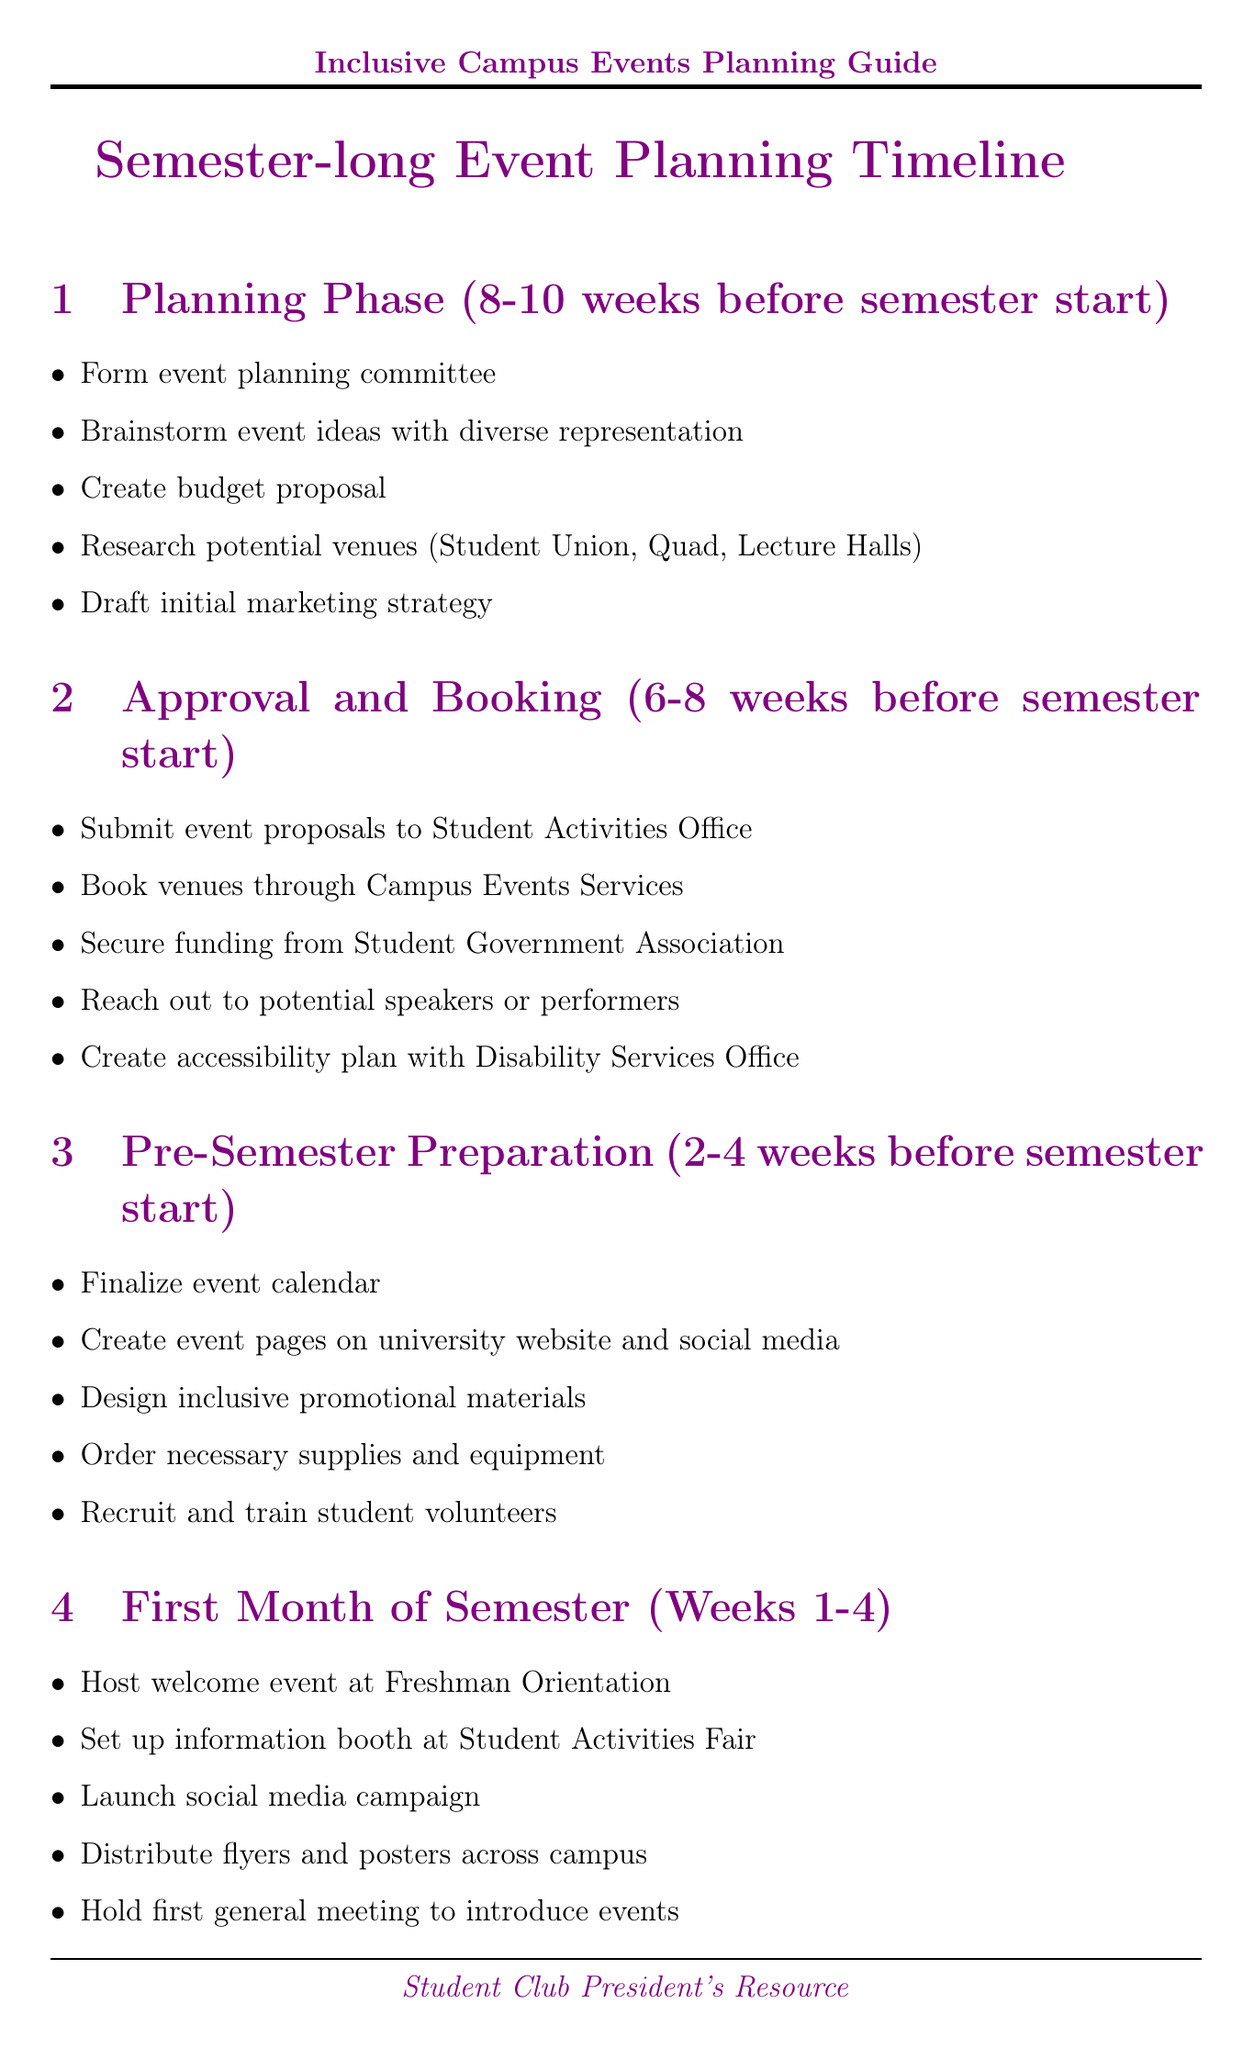what is the timeline for the Planning Phase? The timeline for the Planning Phase is specified as "8-10 weeks before semester start".
Answer: 8-10 weeks before semester start who is the Campus Events Coordinator? The document lists Michael Lee as the Campus Events Coordinator.
Answer: Michael Lee when is the Room Reservation Deadline? The Room Reservation Deadline is detailed as "4 weeks before semester start".
Answer: 4 weeks before semester start what task involves diverse representation? The task that involves diverse representation is "Brainstorm event ideas with diverse representation".
Answer: Brainstorm event ideas with diverse representation what should be created with the Disability Services Office? The document specifies that an "accessibility plan" should be created with the Disability Services Office.
Answer: accessibility plan how many tasks are listed for the End-of-Semester Wrap-up? The End-of-Semester Wrap-up section includes a total of five tasks.
Answer: five tasks what task occurs during Weeks 1-4 of the semester? One of the tasks listed for Weeks 1-4 is "Host welcome event at Freshman Orientation".
Answer: Host welcome event at Freshman Orientation what deadline is set for the last day to place catering orders? The last day to place catering orders is referred to as the "Catering Order Deadline".
Answer: Catering Order Deadline what is the primary focus of the Mid-Semester Check-in? The primary focus of the Mid-Semester Check-in includes "Review event attendance and feedback".
Answer: Review event attendance and feedback 